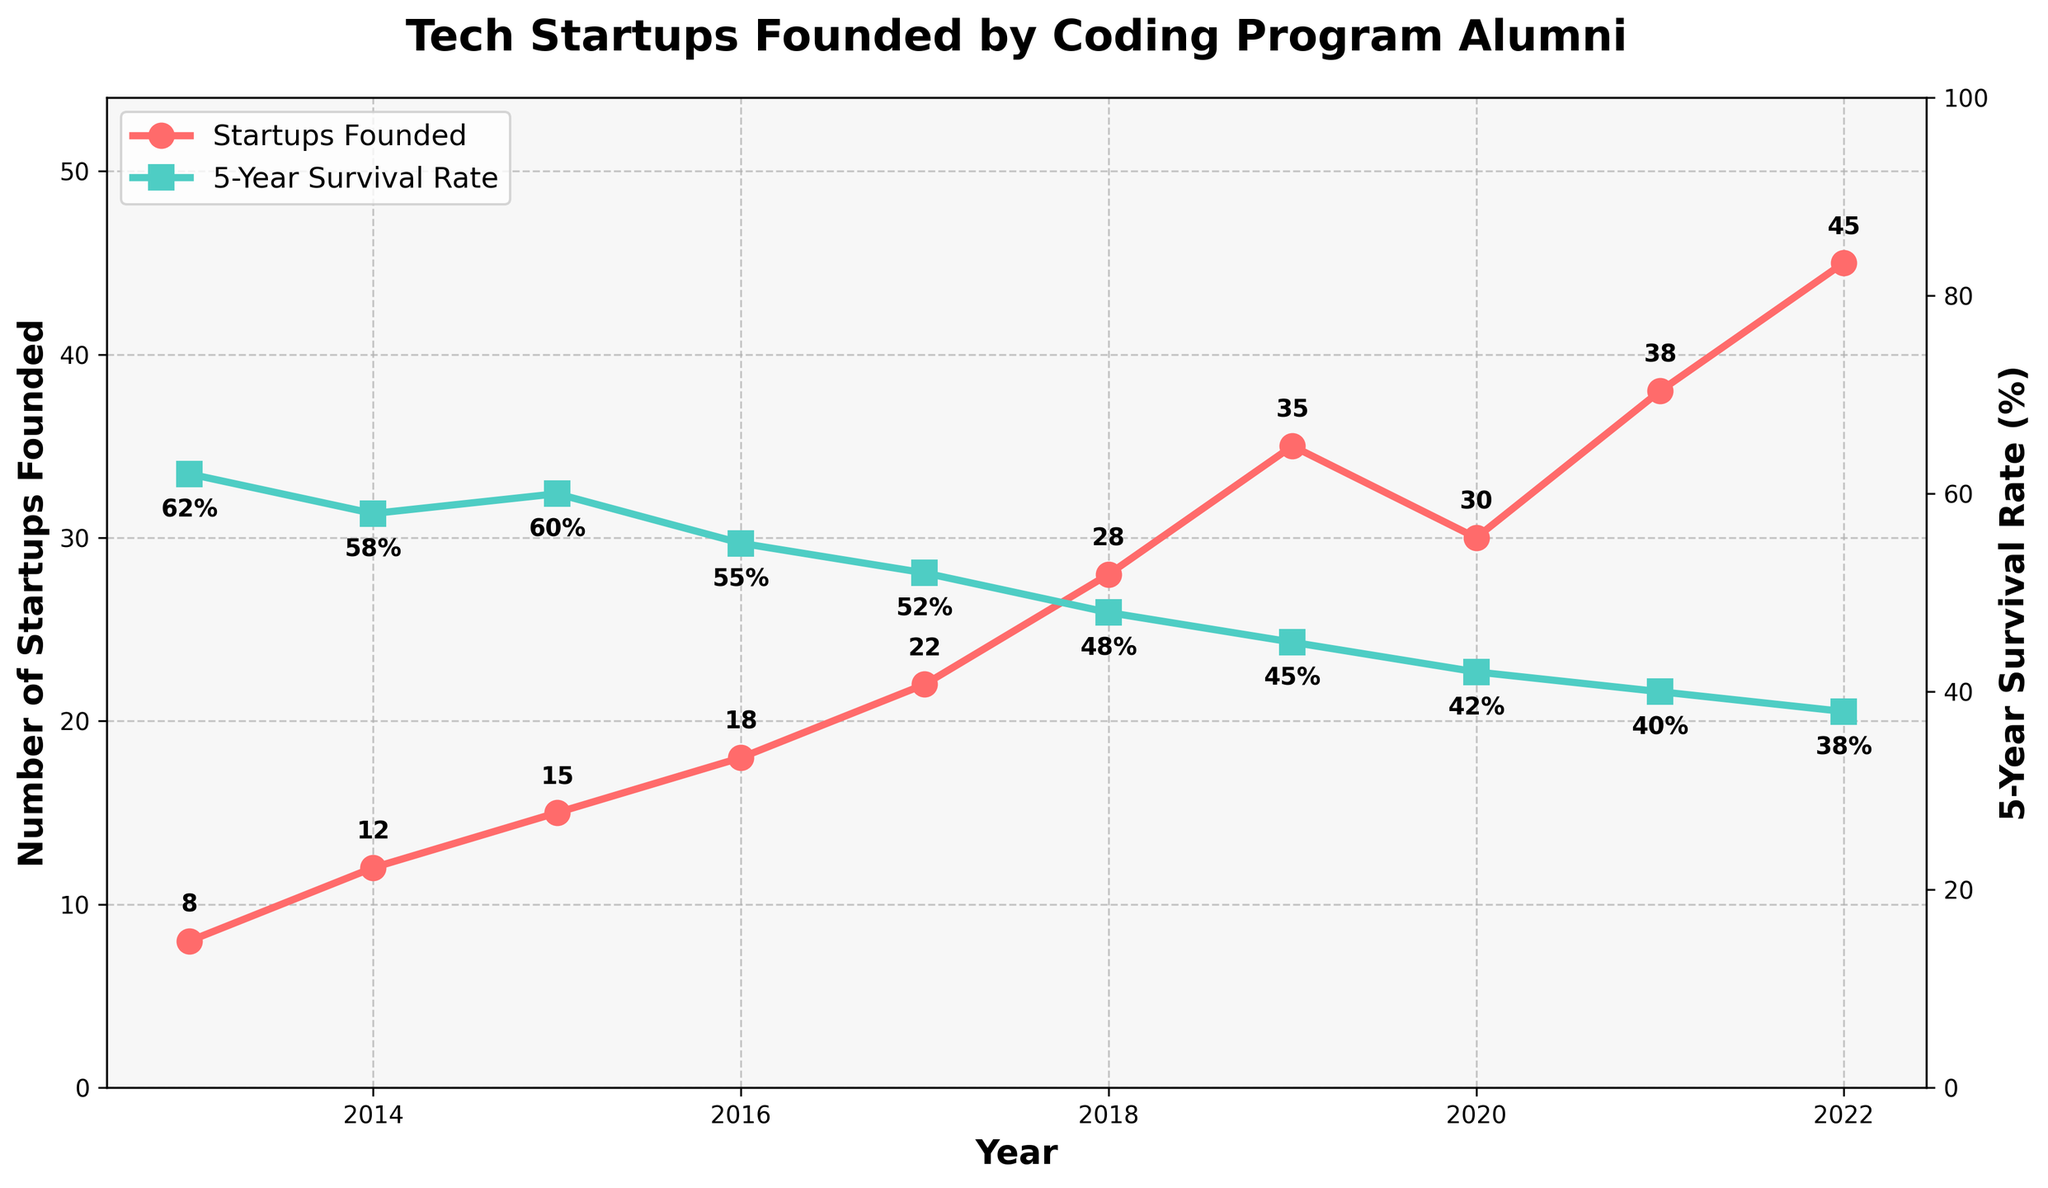What is the total number of startups founded between 2013 and 2018? To find the total, sum up the number of startups founded for each year from 2013 to 2018: 8 + 12 + 15 + 18 + 22 + 28 = 103
Answer: 103 Which year had the highest number of startups founded? Look at the line representing the number of startups founded and identify the year with the highest peak. The highest peak is at 2022 with 45 startups.
Answer: 2022 Has the 5-Year Survival Rate shown an upward or downward trend from 2013 to 2022? Observe the line representing the 5-year survival rate. It starts from 62% in 2013 and continuously decreases to 38% in 2022.
Answer: Downward In which year did the number of startups founded see the most significant increase compared to the previous year? Calculate the difference in the number of startups founded between consecutive years and find the maximum. The largest increase is from 28 in 2018 to 35 in 2019, which is an increase of 7 startups.
Answer: 2019 What is the average 5-Year Survival Rate over the period 2013-2022? First, add up all the annual survival rates, then divide by the number of years. (62 + 58 + 60 + 55 + 52 + 48 + 45 + 42 + 40 + 38) / 10 = 500 / 10 = 50%
Answer: 50% Compare the number of startups founded in 2020 with 2021. Which year has more, and by how much? In 2020, the number of startups founded is 30, whereas in 2021, it's 38. The difference is 38 - 30 = 8, with 2021 having more startups founded.
Answer: 2021; 8 What was the 5-Year Survival Rate in 2015, and how did it compare to 2016? The 5-Year Survival Rate in 2015 was 60%, and in 2016 it was 55%. The rate in 2016 is 5% lower than in 2015.
Answer: 60%; 5% lower Looking at the trend from 2013 to 2022, can you determine if the number of startups founded has increased or decreased over time? The overall trend shows an increase in the number of startups founded from 8 in 2013 to 45 in 2022.
Answer: Increased How many more startups were founded in 2019 compared to 2013? Subtract the number of startups founded in 2013 from those founded in 2019: 35 - 8 = 27.
Answer: 27 What are the visual indicators used to differentiate between the number of startups founded and the 5-Year Survival Rate on the chart? The number of startups founded is represented by a red line with circular markers, while the 5-Year Survival Rate is shown by a green line with square markers.
Answer: Red line, circular markers for startups; Green line, square markers for survival rate 